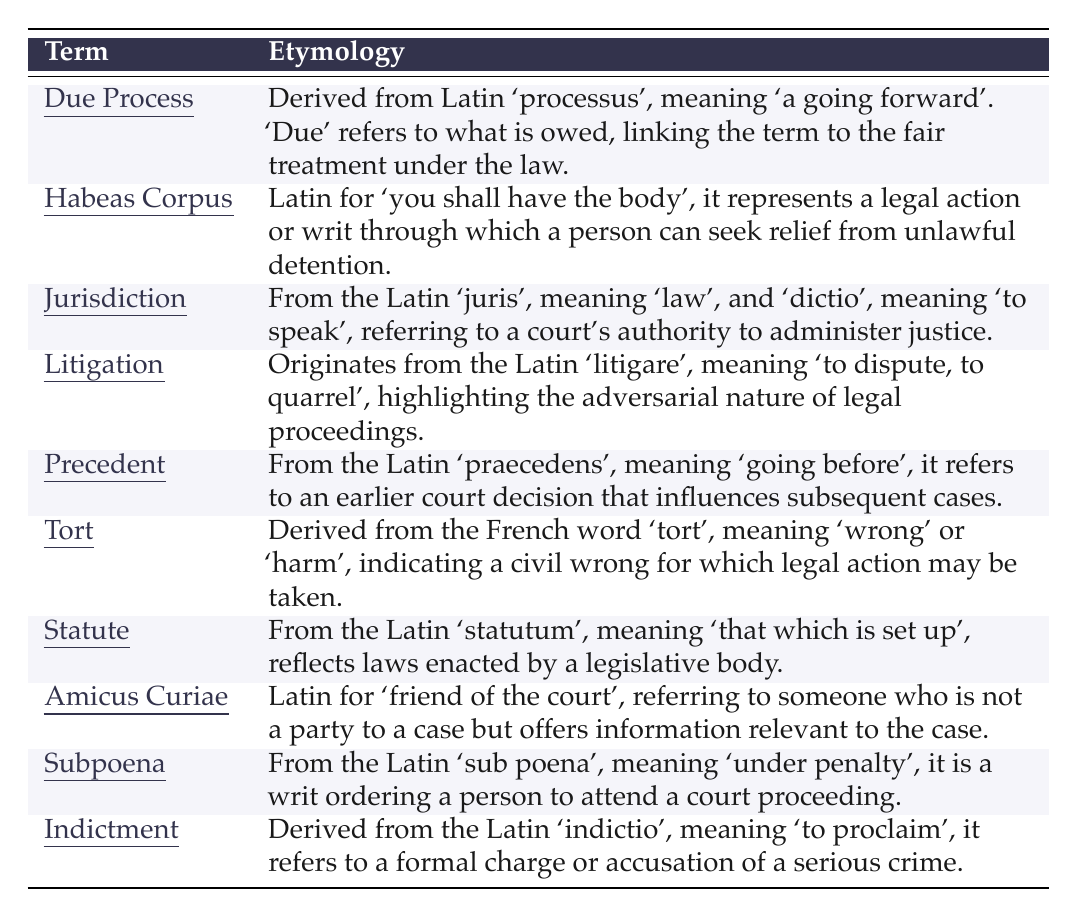What is the etymological origin of "Habeas Corpus"? The table states that "Habeas Corpus" is derived from Latin and translates to "you shall have the body". This indicates its use in legal action regarding unlawful detention.
Answer: Latin for "you shall have the body" Which term is related to the authority of a court? The term "Jurisdiction" in the table is defined as the authority that a court has to administer justice, which connects directly to court authority.
Answer: Jurisdiction Is "Precedent" derived from Latin? Yes, the table confirms that "Precedent" comes from the Latin word "praecedens", meaning "going before", verifying its Latin origin.
Answer: Yes What do the terms "Statute" and "Tort" have in common based on their origins? Both terms originate from Latin or French. "Statute" comes from the Latin "statutum", while "Tort" is derived from the French word "tort", suggesting a link to formal legal definitions across languages.
Answer: They are derived from Latin or French Which term is associated with unlawful detention relief? "Habeas Corpus" is the term specified in the table that expresses the action to relieve unlawful detention, as clarified in its description.
Answer: Habeas Corpus How many terms in the table derive from Latin? The terms "Due Process", "Habeas Corpus", "Jurisdiction", "Litigation", "Precedent", "Statute", "Subpoena", and "Indictment" all have their etymological roots in Latin, totaling 8 terms in the table.
Answer: 8 Does the term "Tort" indicate a civil wrong? Yes, the table defines "Tort" as a civil wrong for which legal action can be taken, affirming its indicative nature.
Answer: Yes Which term implies a person's obligation to attend a court? The term "Subpoena" is cited in the table, where it is described as a writ that orders a person to attend a court proceeding, thus indicating the obligation.
Answer: Subpoena What might be the relationship between "Litigation" and the term "Tort"? Since "Litigation" refers to disputes or quarrels and "Tort" is a civil wrong, disputes arising from torts can lead to litigation, indicating a direct relationship between them based on their definitions.
Answer: They are related through legal disputes Which term suggests a formal charge of a crime? The term "Indictment" indicates a formal charge or accusation of a serious crime, according to the table description.
Answer: Indictment 